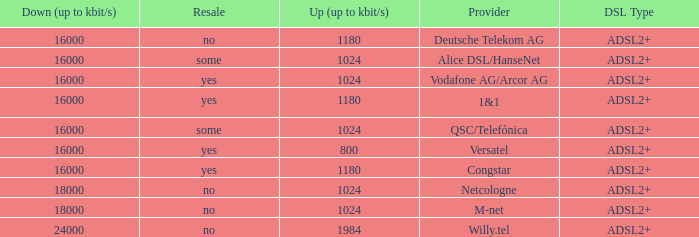What is download bandwith where the provider is deutsche telekom ag? 16000.0. 